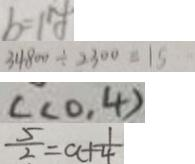<formula> <loc_0><loc_0><loc_500><loc_500>b = 1 y 
 3 4 8 0 0 \div 2 3 0 0 = 1 5 
 c ( 0 . 4 ) 
 \frac { 5 } { 2 } = a + \frac { 1 } { 4 }</formula> 